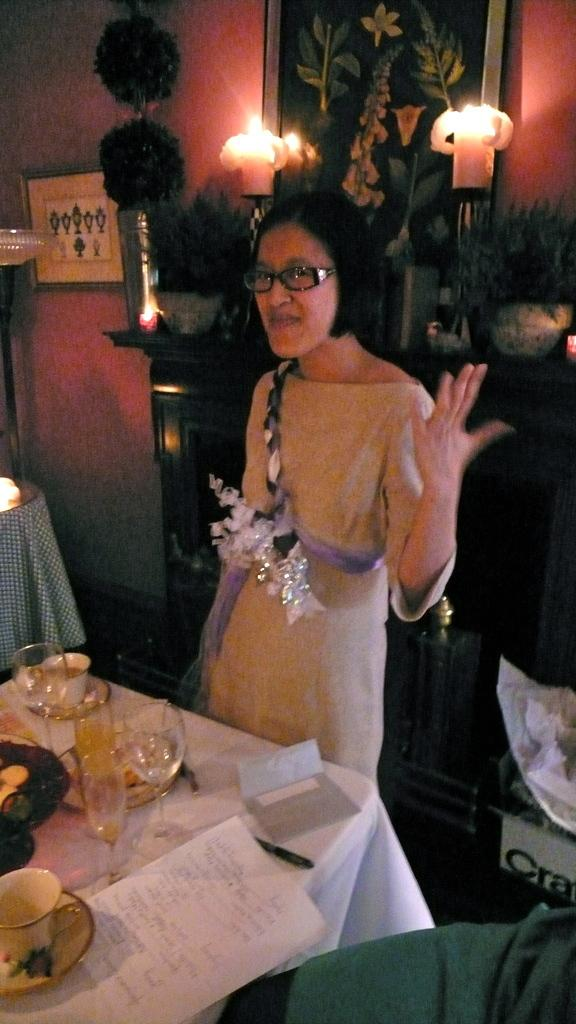What is the main subject of the image? There is a person standing in the image. What object is present near the person? There is a table in the image. What items can be seen on the table? There is a glass, a bowl, and a paper on the table. What can be seen in the background of the image? The background of the image includes flower pots and a photo frame. What caption is written on the paper in the image? There is no caption visible on the paper in the image; it is not mentioned in the provided facts. 